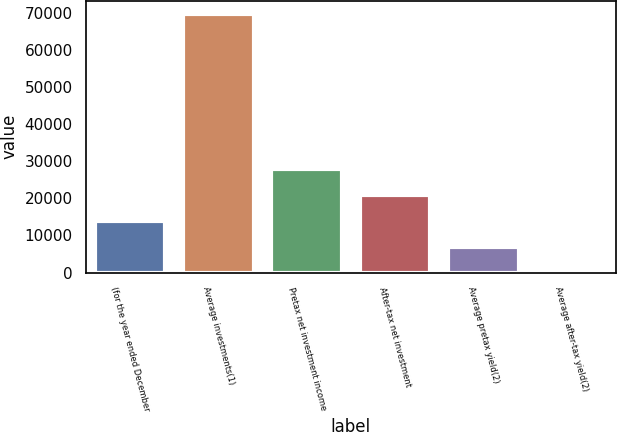Convert chart. <chart><loc_0><loc_0><loc_500><loc_500><bar_chart><fcel>(for the year ended December<fcel>Average investments(1)<fcel>Pretax net investment income<fcel>After-tax net investment<fcel>Average pretax yield(2)<fcel>Average after-tax yield(2)<nl><fcel>13975.2<fcel>69863<fcel>27947.2<fcel>20961.2<fcel>6989.27<fcel>3.3<nl></chart> 